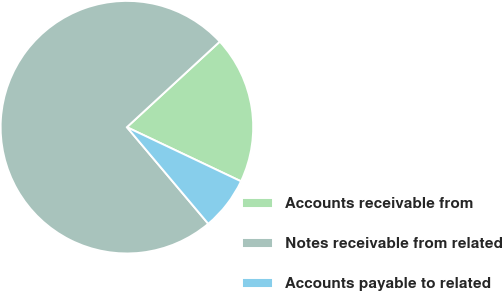Convert chart. <chart><loc_0><loc_0><loc_500><loc_500><pie_chart><fcel>Accounts receivable from<fcel>Notes receivable from related<fcel>Accounts payable to related<nl><fcel>18.9%<fcel>74.29%<fcel>6.81%<nl></chart> 